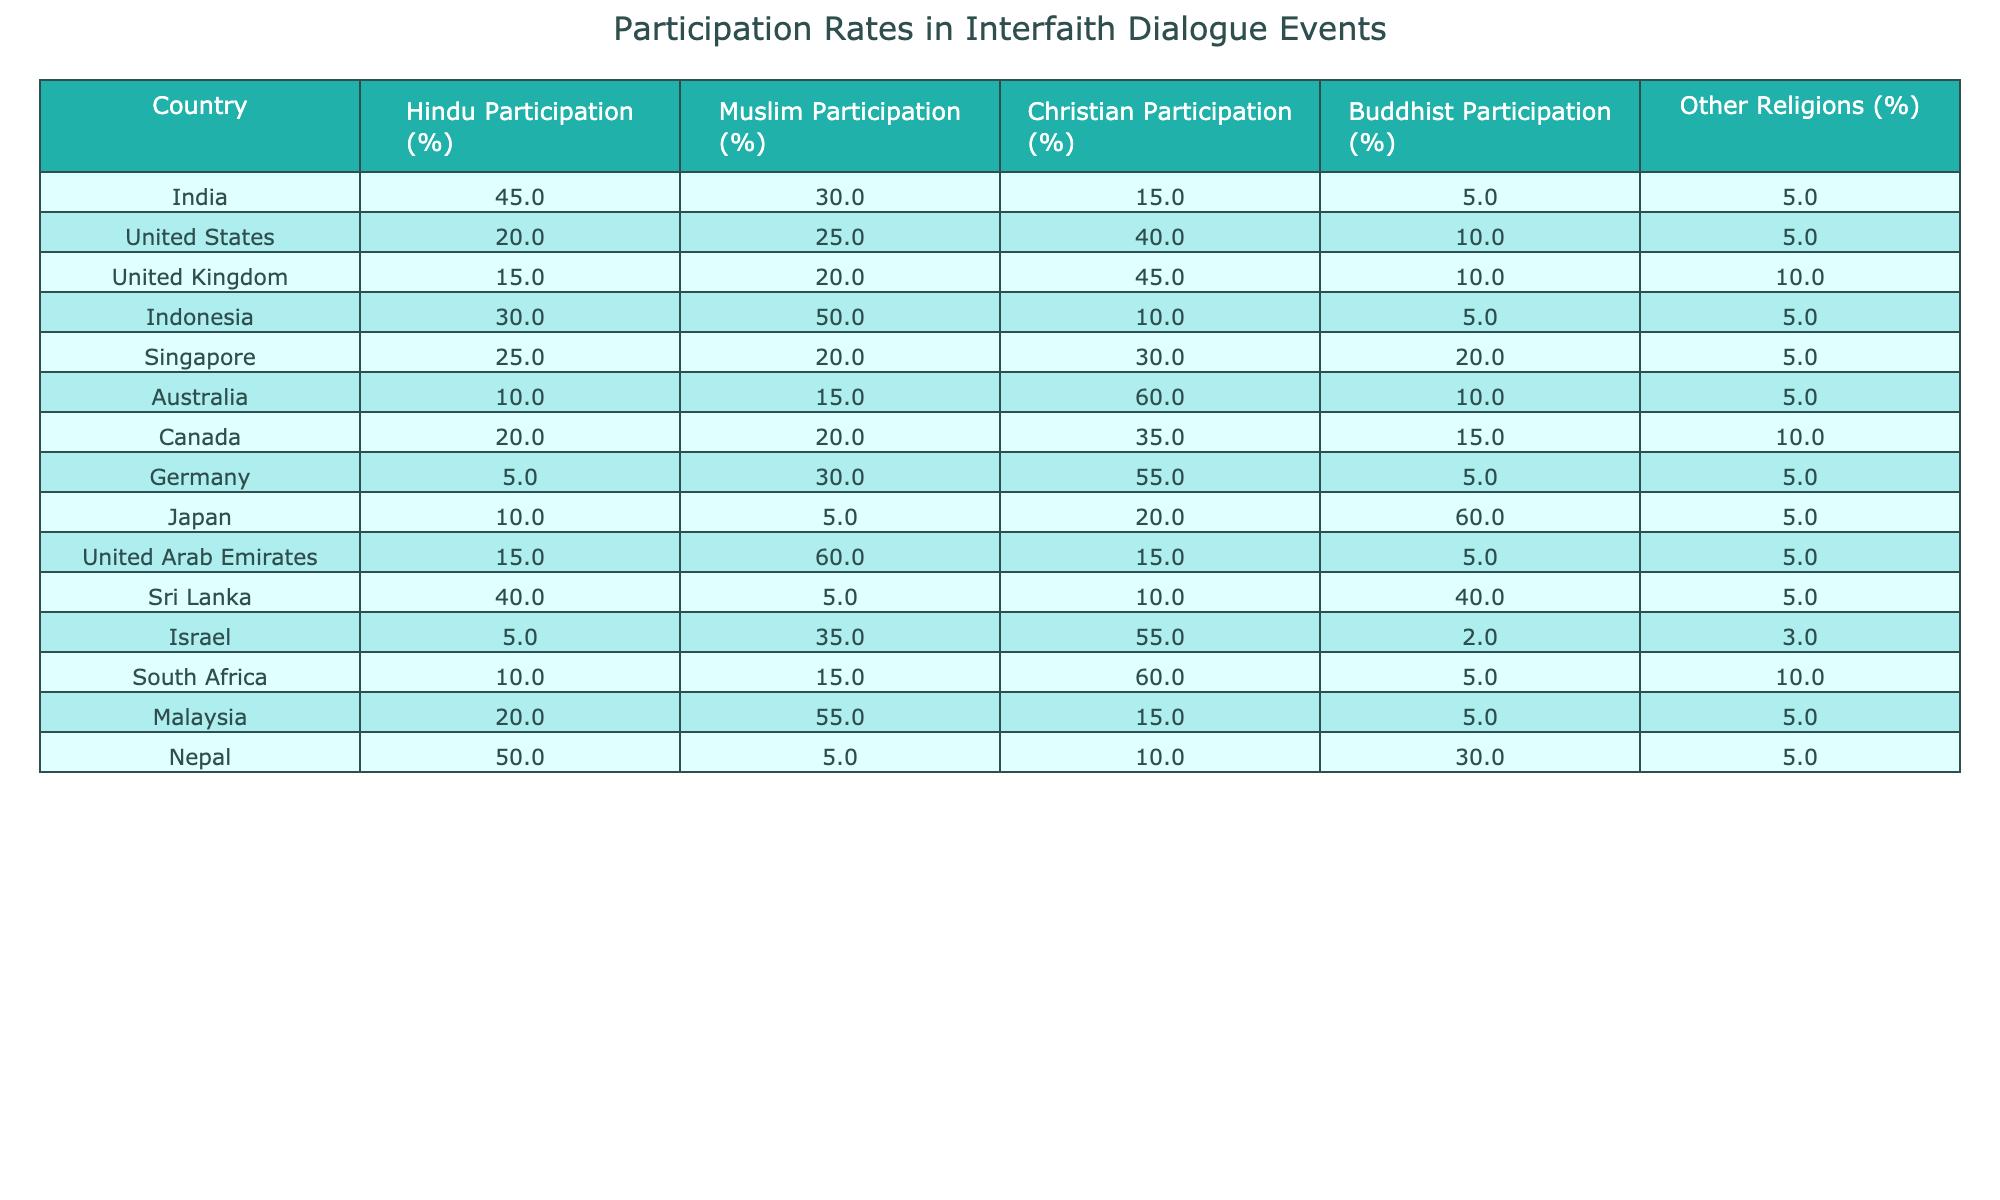What country has the highest Hindu participation in interfaith dialogues? By examining the Hindu Participation (%) column, I see that Nepal has the highest rate at 50%.
Answer: Nepal Which country reported the highest total number of participants in an interfaith dialogue event? The Total Participants column shows that the United Arab Emirates has the highest number with 1500 participants.
Answer: United Arab Emirates What is the average Muslim participation percentage across all countries listed? I will sum the Muslim Participation percentages, which are 30, 25, 20, 50, 20, 15, 20, 30, 5, 60, 55, 15, 55, and 5 = 485. There are 14 data points, so the average is 485/14 = approximately 34.64%.
Answer: 34.64% Which country has the lowest Christian participation percentage? Looking at the Christian Participation (%) column, I see that Sri Lanka has the lowest rate at 10%.
Answer: Sri Lanka Is Hindu participation greater than Muslim participation in India? In India, Hindu Participation is 45% while Muslim Participation is 30%, therefore Hindu participation is greater.
Answer: Yes Find the country where Buddhist participation is the highest. Referring to the Buddhist Participation (%) column, Japan has the highest rate at 60%.
Answer: Japan What is the difference in Hindu participation between India and Sri Lanka? Hindu Participation in India is 45% and in Sri Lanka it is 40%. The difference is 45 - 40 = 5%.
Answer: 5% Which countries have a higher participation rate for Christians compared to Hindus? I will compare the Christian Participation (%) and Hindu Participation (%) for all countries. United Kingdom, Australia, Germany, and Israel have higher Christian rates (45%, 60%, 55%, 55%) compared to Hindu rates (15%, 10%, 5%, 5%).
Answer: United Kingdom, Australia, Germany, Israel What is the median of the total participants across all listed countries? First, I will arrange the Total Participants values in ascending order: 200, 250, 300, 350, 400, 500, 550, 600, 600, 700, 800, 950, 1200, 1500. The median is the average of the 7th and 8th values, (550 + 600)/2 = 575.
Answer: 575 Which country shows the least diversity in participation (highest percentage in one demographic)? By examining the countries with high concentration in one group, Australia has the highest Christian participation at 60% and the lowest Hindu at 10%, indicating less diversity.
Answer: Australia 